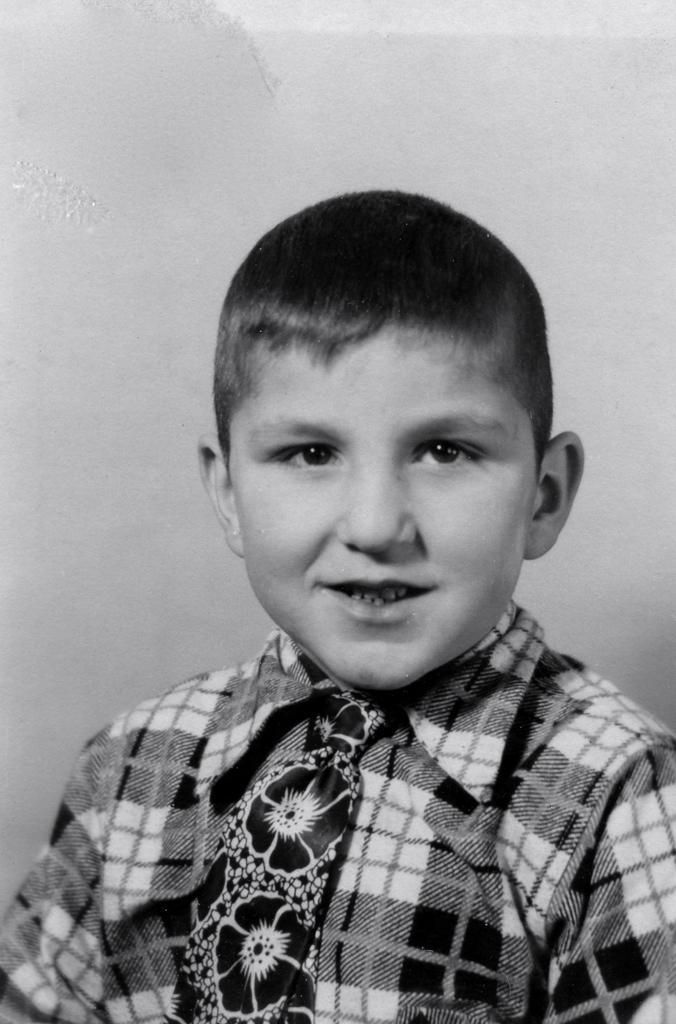Can you describe this image briefly? In the image we can see the black and white picture of the boy, he is wearing clothes and the tie. 